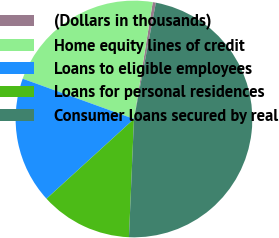Convert chart to OTSL. <chart><loc_0><loc_0><loc_500><loc_500><pie_chart><fcel>(Dollars in thousands)<fcel>Home equity lines of credit<fcel>Loans to eligible employees<fcel>Loans for personal residences<fcel>Consumer loans secured by real<nl><fcel>0.43%<fcel>22.01%<fcel>17.29%<fcel>12.56%<fcel>47.71%<nl></chart> 